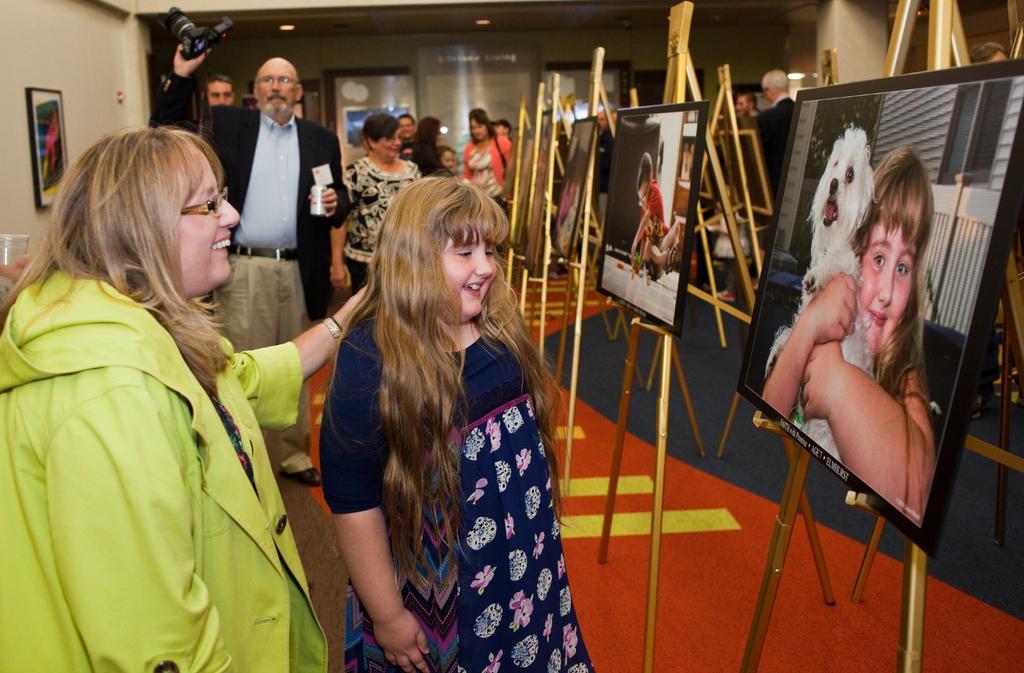Could you give a brief overview of what you see in this image? This picture shows few people standing and we see photo frames and people watching them and a man holds a camera in his hand 